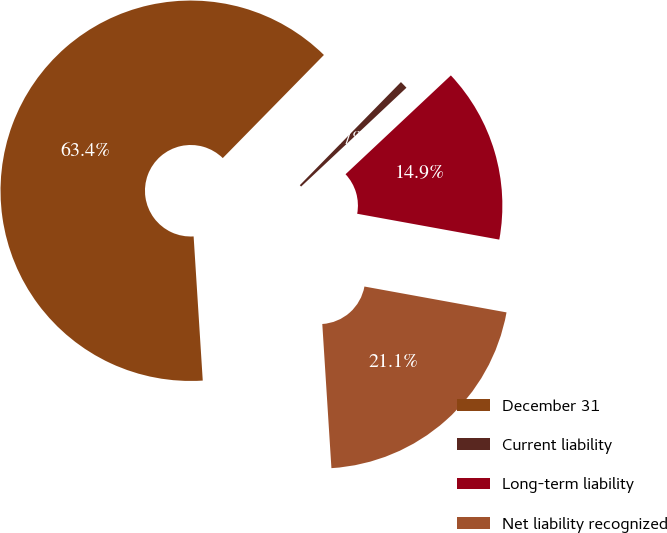Convert chart to OTSL. <chart><loc_0><loc_0><loc_500><loc_500><pie_chart><fcel>December 31<fcel>Current liability<fcel>Long-term liability<fcel>Net liability recognized<nl><fcel>63.36%<fcel>0.66%<fcel>14.86%<fcel>21.13%<nl></chart> 